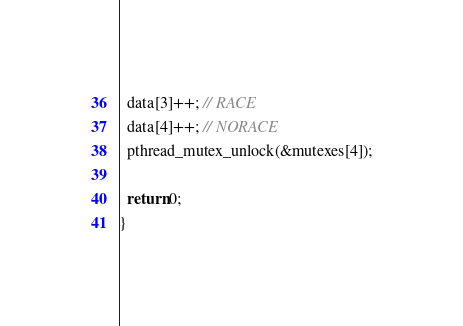Convert code to text. <code><loc_0><loc_0><loc_500><loc_500><_C_>  data[3]++; // RACE
  data[4]++; // NORACE
  pthread_mutex_unlock(&mutexes[4]);

  return 0;
}
</code> 